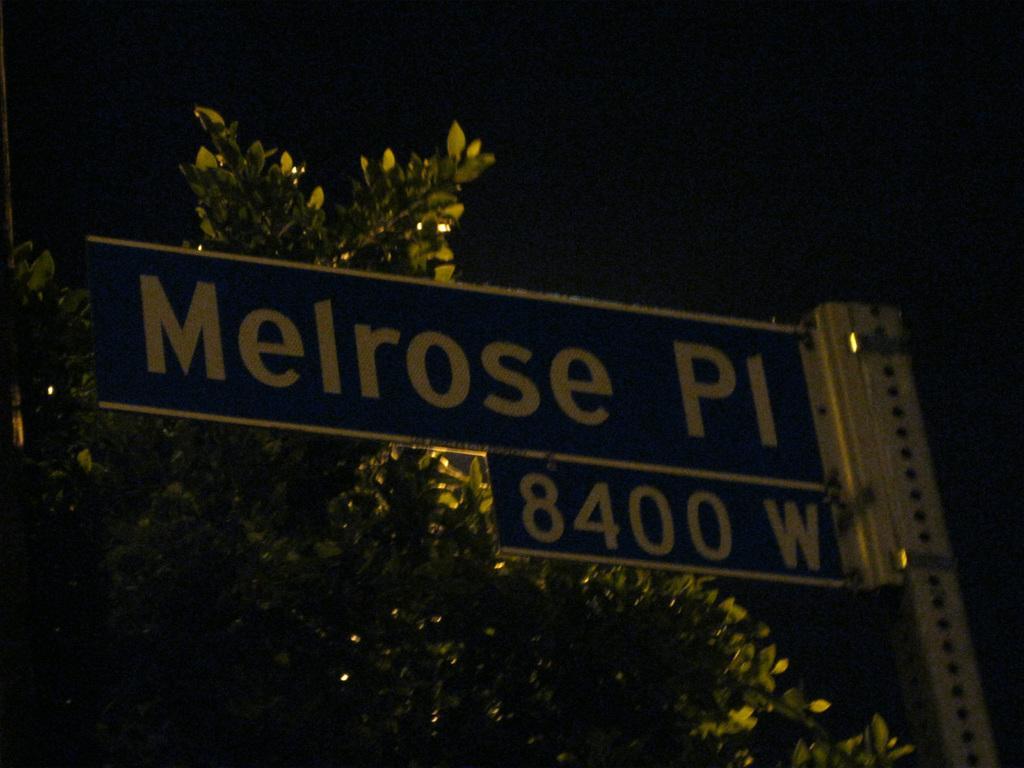Can you describe this image briefly? In this image we can see a name board, tree and sky. 